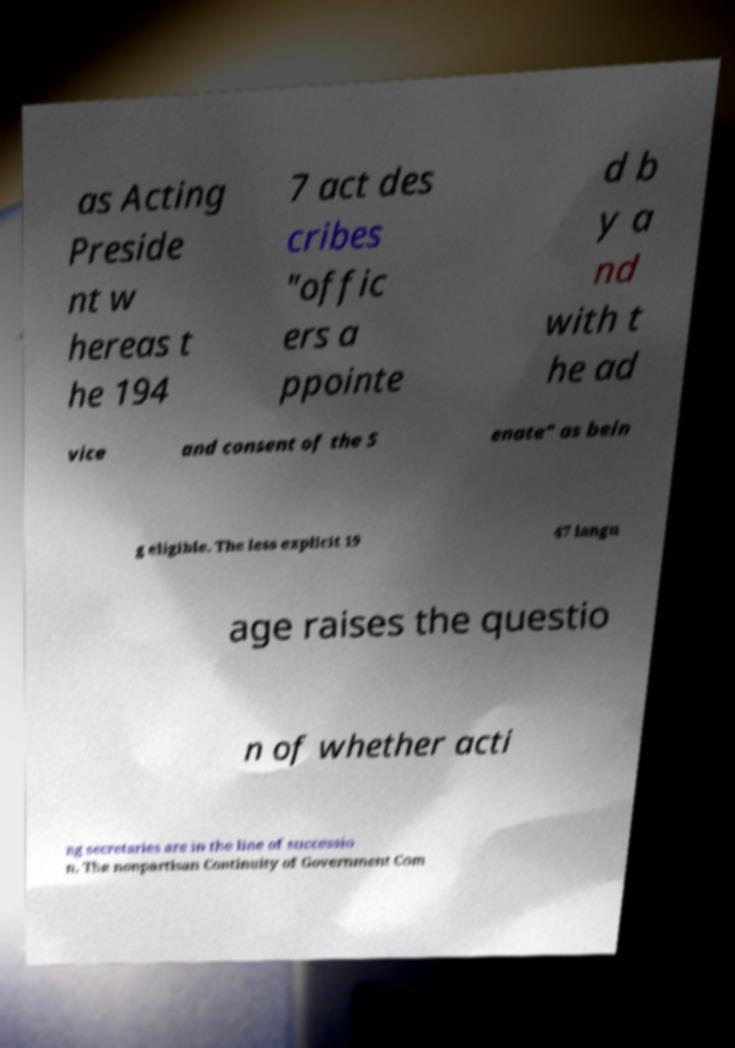There's text embedded in this image that I need extracted. Can you transcribe it verbatim? as Acting Preside nt w hereas t he 194 7 act des cribes "offic ers a ppointe d b y a nd with t he ad vice and consent of the S enate" as bein g eligible. The less explicit 19 47 langu age raises the questio n of whether acti ng secretaries are in the line of successio n. The nonpartisan Continuity of Government Com 